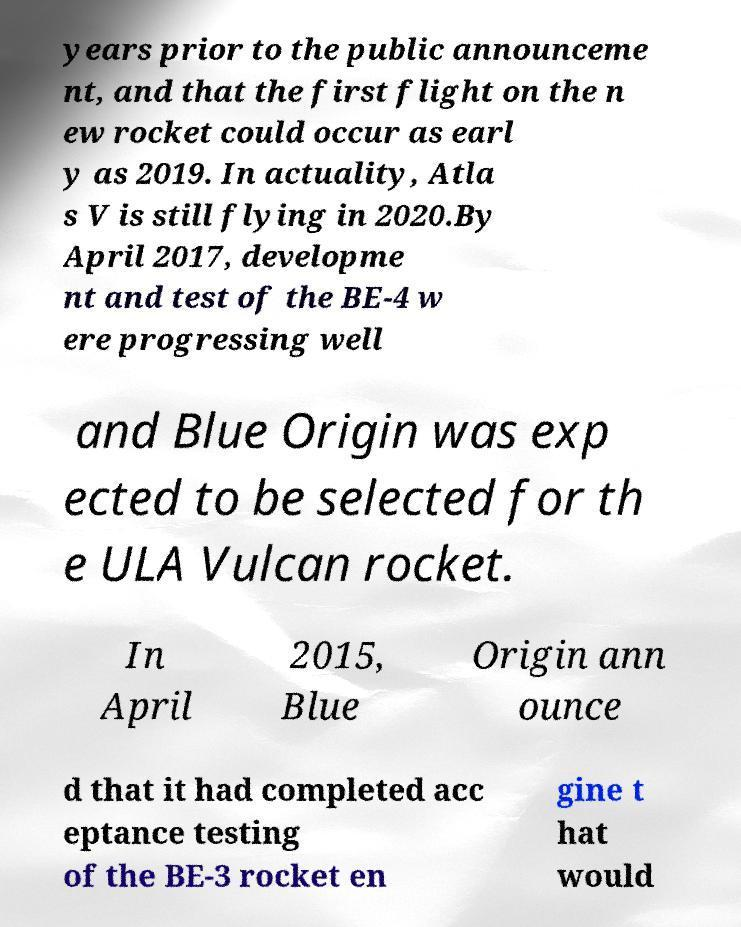I need the written content from this picture converted into text. Can you do that? years prior to the public announceme nt, and that the first flight on the n ew rocket could occur as earl y as 2019. In actuality, Atla s V is still flying in 2020.By April 2017, developme nt and test of the BE-4 w ere progressing well and Blue Origin was exp ected to be selected for th e ULA Vulcan rocket. In April 2015, Blue Origin ann ounce d that it had completed acc eptance testing of the BE-3 rocket en gine t hat would 